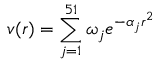Convert formula to latex. <formula><loc_0><loc_0><loc_500><loc_500>v ( r ) = \sum _ { j = 1 } ^ { 5 1 } \omega _ { j } e ^ { - \alpha _ { j } r ^ { 2 } }</formula> 